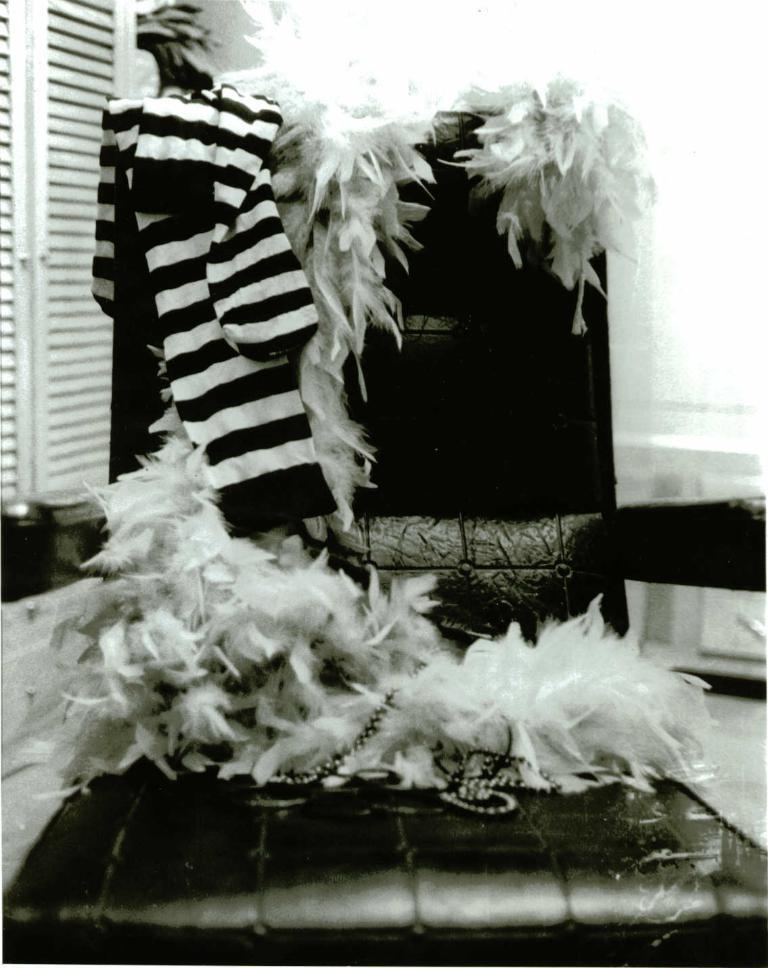What is the color scheme of the image? The image is black and white. What type of furniture can be seen in the image? There is a chair in the image. What is on the chair in the image? Clothes are present on the chair. What type of basketball shoes is the mother wearing in the image? There is no mother or basketball shoes present in the image; it is a black and white image of a chair with clothes on it. 